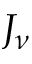<formula> <loc_0><loc_0><loc_500><loc_500>J _ { \nu }</formula> 